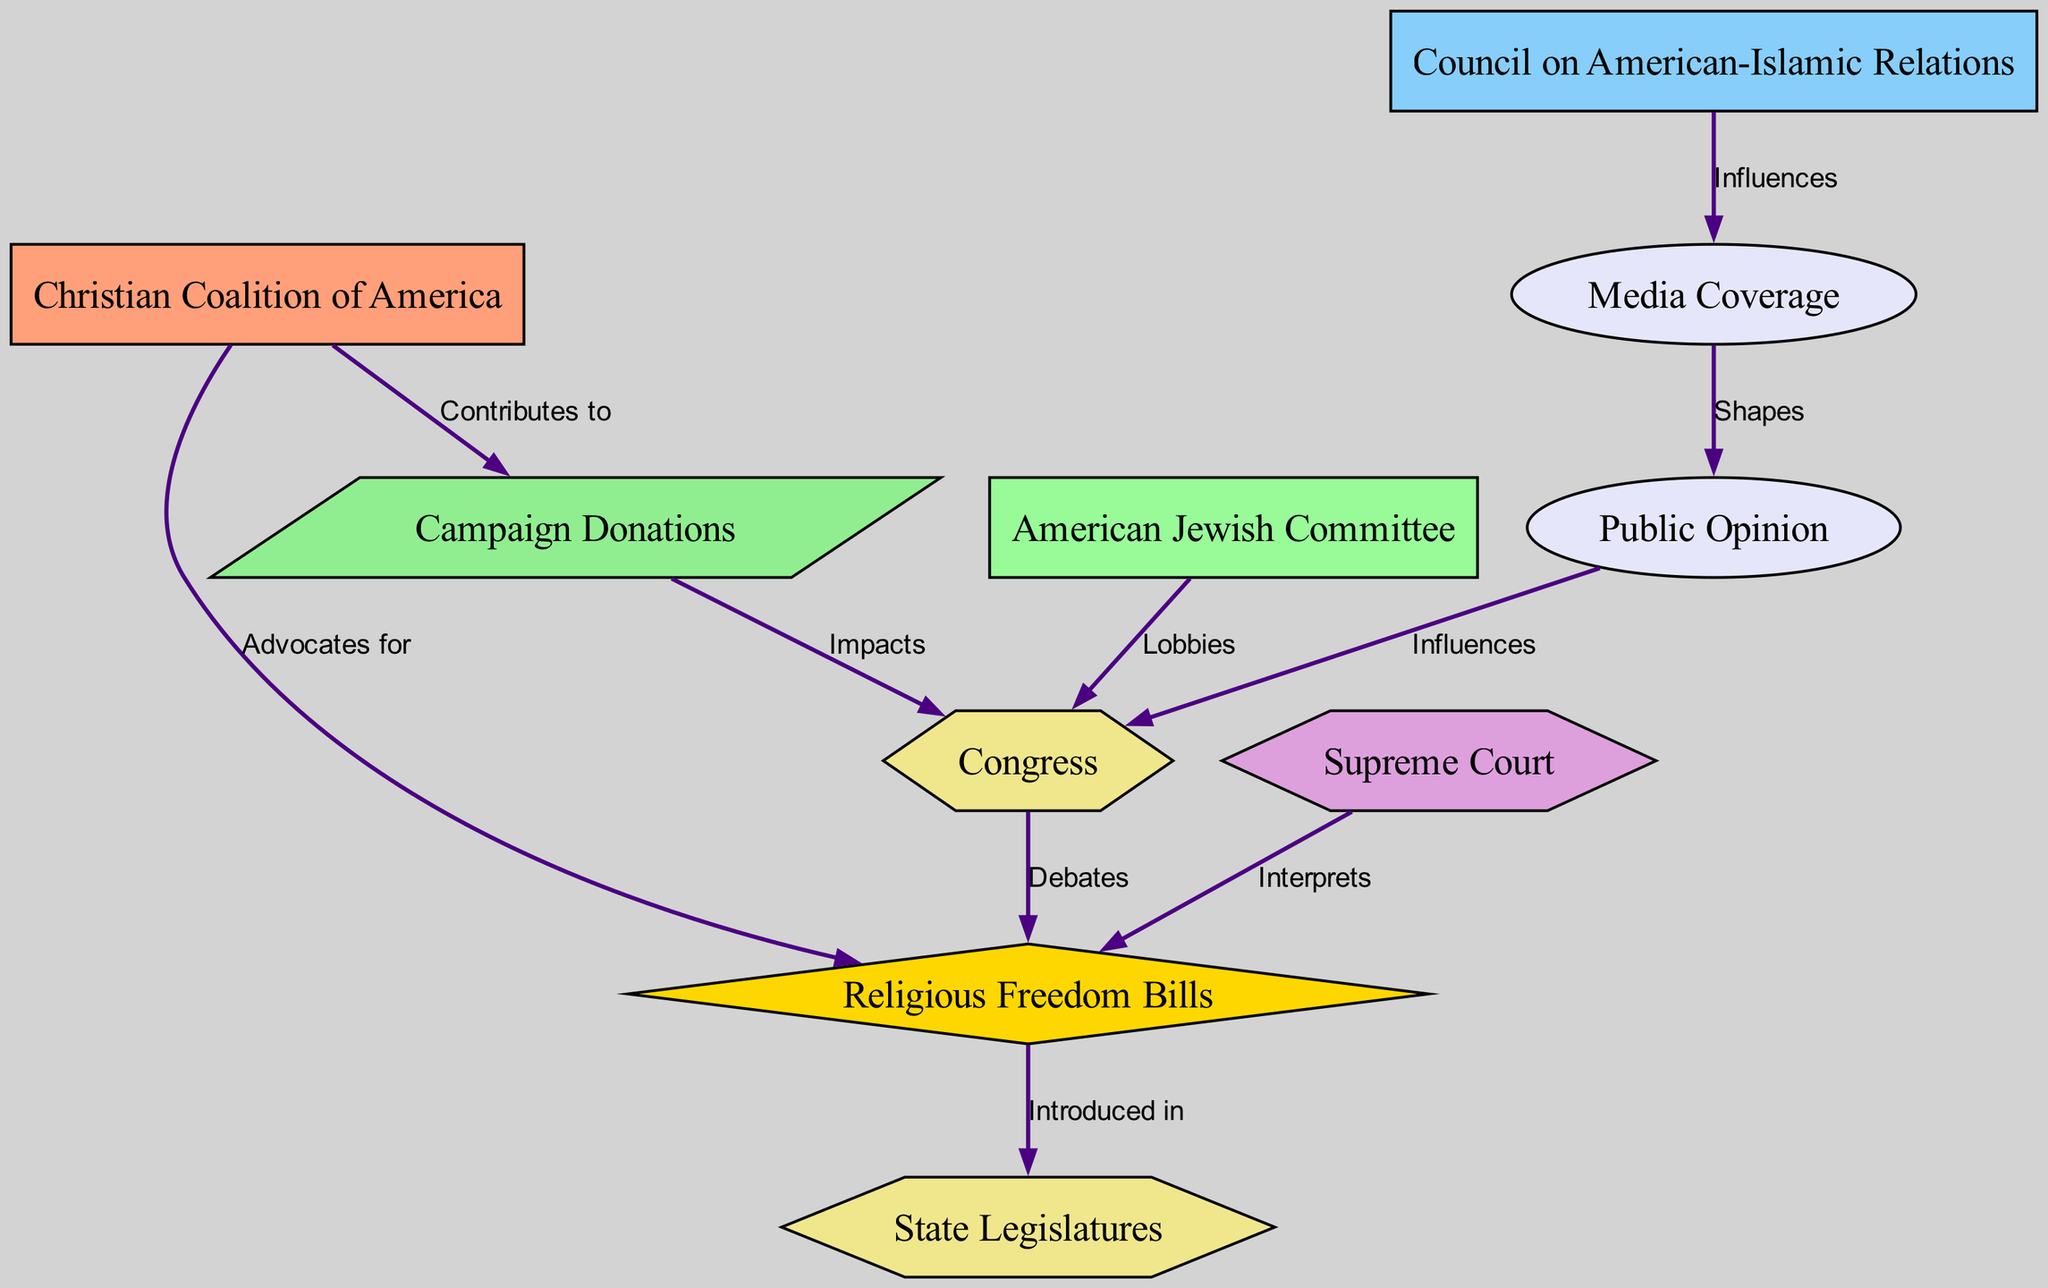What lobbying group advocates for Religious Freedom Bills? The diagram shows a directed edge from the "Christian Coalition of America" to "Religious Freedom Bills" labeled "Advocates for." This indicates that the Christian Coalition of America is the group advocating for these bills.
Answer: Christian Coalition of America Which group lobbies Congress according to the diagram? The diagram shows a directed edge from the "American Jewish Committee" to "Congress" labeled "Lobbies." This signifies that the American Jewish Committee is directly involved in lobbying efforts towards Congress.
Answer: American Jewish Committee How many total nodes are present in the diagram? By counting each unique entity listed under "nodes," we find there are ten different nodes present in the diagram.
Answer: 10 What impacts Congress according to the diagram? The diagram indicates two distinct connections showing that "Campaign Donations" impacts Congress, and "Public Opinion" also influences Congress. Both effects are noted in the edges directed towards Congress.
Answer: Campaign Donations, Public Opinion What does the "Media Coverage" influence? The diagram illustrates a mechanism where "Media Coverage" shapes "Public Opinion." The directed edge from Media Coverage to Public Opinion shows this influence.
Answer: Public Opinion Which entity interprets Religious Freedom Bills? In the diagram, the "Supreme Court" has a directed edge pointing to "Religious Freedom Bills" labeled "Interprets," indicating that it plays a role in interpreting these legislative measures.
Answer: Supreme Court Which lobbying group contributes to Campaign Donations? The diagram clearly states that the "Christian Coalition of America" contributes to "Campaign Donations," as evidenced by the directed edge from the Christian Coalition to Campaign Donations labeled "Contributes to."
Answer: Christian Coalition of America In which legislative body are Religious Freedom Bills introduced? The diagram shows that "Religious Freedom Bills" have a directed edge towards "State Legislatures" labeled "Introduced in," indicating that these bills are presented in state legislative bodies.
Answer: State Legislatures What shapes Public Opinion in the diagram? The relationship illustrated in the diagram shows that "Media Coverage" shapes "Public Opinion." This is reflected in the directed edge connecting these two nodes.
Answer: Media Coverage 